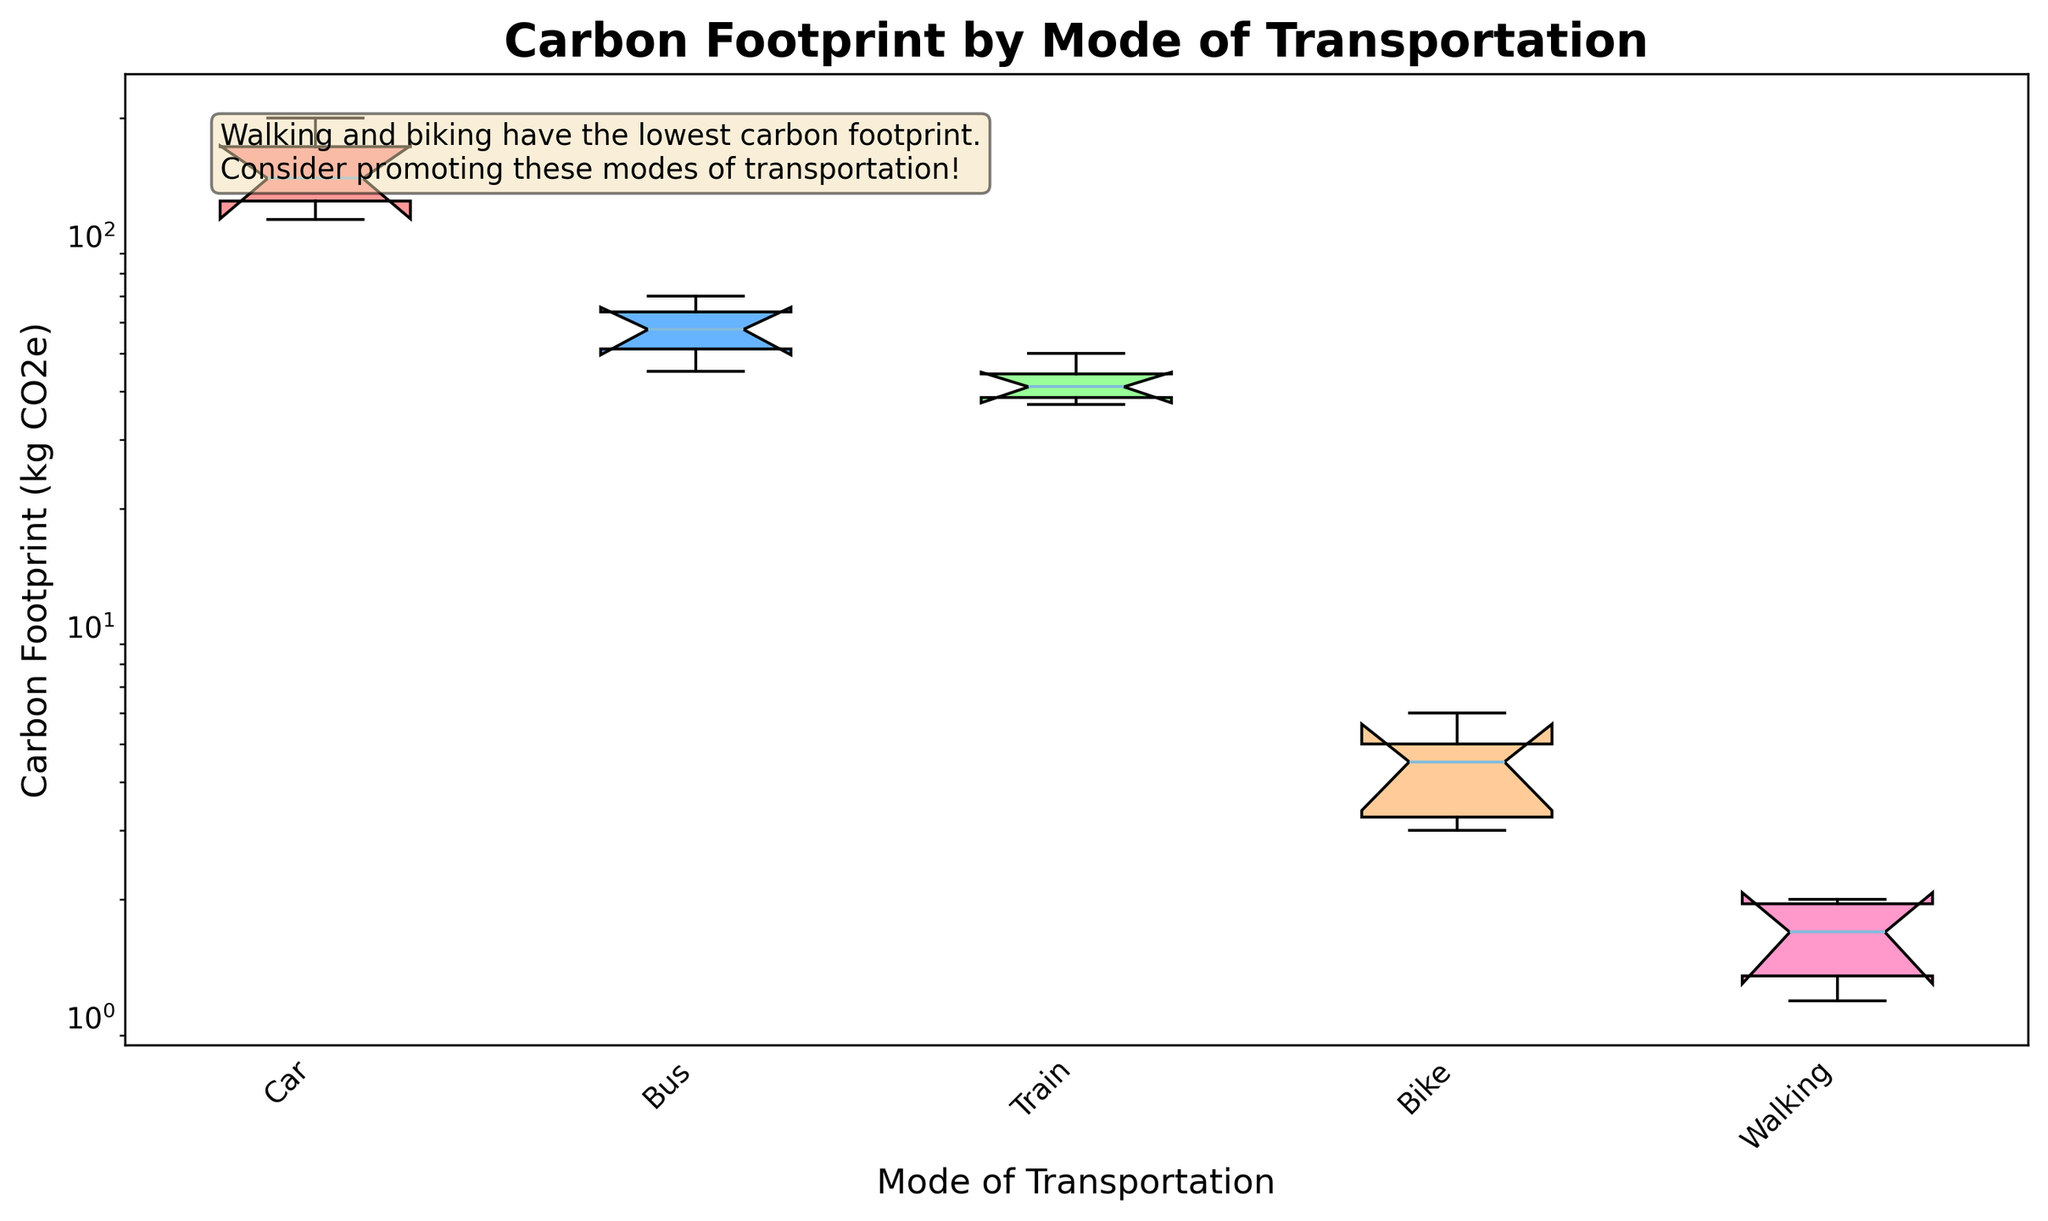What is the title of the plot? The title is at the top of the plot in a bold font, indicating the main topic of the visualization.
Answer: Carbon Footprint by Mode of Transportation Which mode of transportation has the lowest carbon footprint? From the plot, you can see the box plots for each transportation mode and notice which one has the lowest values.
Answer: Walking Which mode of transportation has the highest median carbon footprint? The median is the middle line inside each box. By comparing these lines across the different modes of transportation, you can identify the highest one.
Answer: Car What is the approximate range of the carbon footprint for cars? The range is the difference between the maximum and minimum values. You can observe this from the ends of the whiskers in the box plot for cars.
Answer: 110 to 200 kg CO2e Which transportation mode has the smallest interquartile range (IQR)? The IQR is the height of the box, indicating the range between the first and third quartiles. By comparing the boxes, the smallest IQR is identified.
Answer: Walking How does the carbon footprint of biking compare to that of taking the bus? By looking at the boxes and medians of both modes, you can compare their central tendencies and variability.
Answer: Biking is much lower than the bus What sustainability message is included in the plot? The text box in the plot contains a message emphasizing the environmental impact.
Answer: Walking and biking have the lowest carbon footprint. Consider promoting these modes of transportation! Are there any modes of transportation that have overlapping confidence intervals in the notches? The notches represent the confidence interval around the median. Check if any notches overlap to assess if there's a significant difference between medians.
Answer: No, the notches do not overlap What does the y-axis represent? The label next to the y-axis clearly describes what is being measured on this axis.
Answer: Carbon Footprint (kg CO2e) Which mode of transportation has the widest spread of carbon footprint values? The spread is determined by the length of the whiskers and the range of the box plot for each mode.
Answer: Car 